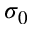<formula> <loc_0><loc_0><loc_500><loc_500>\sigma _ { 0 }</formula> 